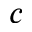Convert formula to latex. <formula><loc_0><loc_0><loc_500><loc_500>c</formula> 